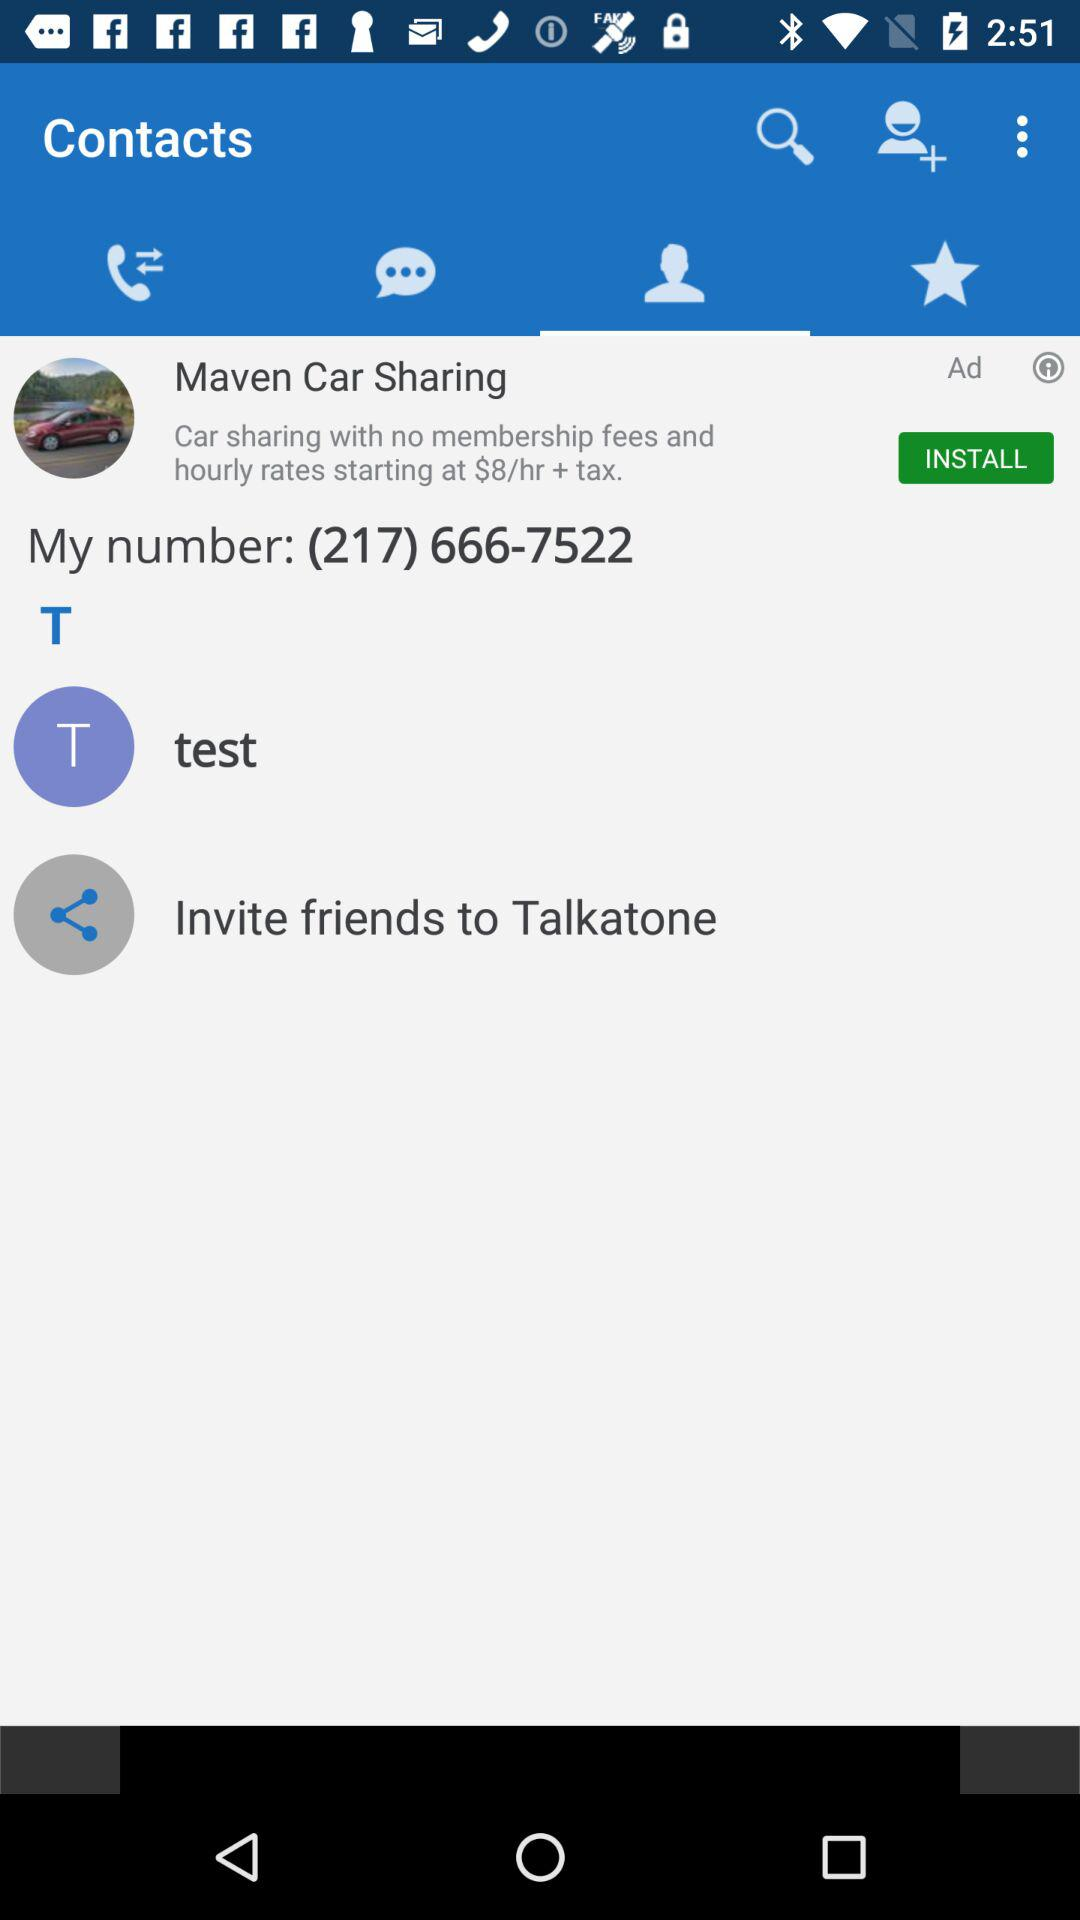What is the number? The number is (217) 666-7522. 